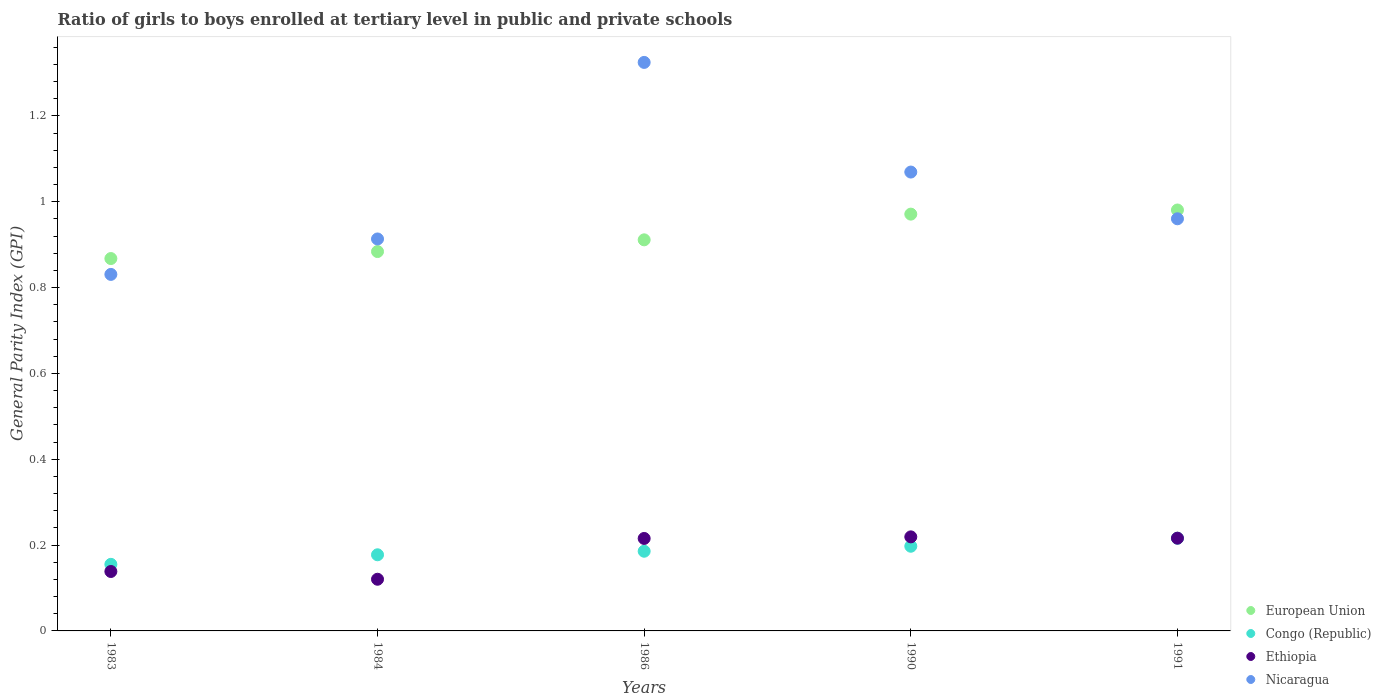Is the number of dotlines equal to the number of legend labels?
Give a very brief answer. Yes. What is the general parity index in European Union in 1986?
Offer a very short reply. 0.91. Across all years, what is the maximum general parity index in Ethiopia?
Your answer should be very brief. 0.22. Across all years, what is the minimum general parity index in European Union?
Provide a short and direct response. 0.87. In which year was the general parity index in European Union maximum?
Your answer should be very brief. 1991. In which year was the general parity index in Nicaragua minimum?
Give a very brief answer. 1983. What is the total general parity index in European Union in the graph?
Keep it short and to the point. 4.62. What is the difference between the general parity index in Ethiopia in 1984 and that in 1991?
Give a very brief answer. -0.1. What is the difference between the general parity index in European Union in 1983 and the general parity index in Ethiopia in 1990?
Make the answer very short. 0.65. What is the average general parity index in Congo (Republic) per year?
Your response must be concise. 0.19. In the year 1986, what is the difference between the general parity index in Congo (Republic) and general parity index in Nicaragua?
Provide a short and direct response. -1.14. In how many years, is the general parity index in European Union greater than 1.12?
Provide a short and direct response. 0. What is the ratio of the general parity index in European Union in 1986 to that in 1991?
Offer a very short reply. 0.93. Is the general parity index in European Union in 1986 less than that in 1990?
Give a very brief answer. Yes. Is the difference between the general parity index in Congo (Republic) in 1986 and 1990 greater than the difference between the general parity index in Nicaragua in 1986 and 1990?
Your answer should be compact. No. What is the difference between the highest and the second highest general parity index in Ethiopia?
Give a very brief answer. 0. What is the difference between the highest and the lowest general parity index in Congo (Republic)?
Your answer should be compact. 0.06. In how many years, is the general parity index in Congo (Republic) greater than the average general parity index in Congo (Republic) taken over all years?
Offer a terse response. 2. Is the sum of the general parity index in Ethiopia in 1984 and 1990 greater than the maximum general parity index in European Union across all years?
Offer a very short reply. No. Is it the case that in every year, the sum of the general parity index in Congo (Republic) and general parity index in European Union  is greater than the sum of general parity index in Ethiopia and general parity index in Nicaragua?
Your answer should be compact. No. Is the general parity index in Ethiopia strictly greater than the general parity index in European Union over the years?
Your response must be concise. No. Are the values on the major ticks of Y-axis written in scientific E-notation?
Give a very brief answer. No. Does the graph contain any zero values?
Ensure brevity in your answer.  No. Where does the legend appear in the graph?
Keep it short and to the point. Bottom right. How many legend labels are there?
Provide a short and direct response. 4. What is the title of the graph?
Provide a short and direct response. Ratio of girls to boys enrolled at tertiary level in public and private schools. Does "Bhutan" appear as one of the legend labels in the graph?
Offer a terse response. No. What is the label or title of the X-axis?
Offer a very short reply. Years. What is the label or title of the Y-axis?
Offer a very short reply. General Parity Index (GPI). What is the General Parity Index (GPI) of European Union in 1983?
Ensure brevity in your answer.  0.87. What is the General Parity Index (GPI) in Congo (Republic) in 1983?
Your response must be concise. 0.16. What is the General Parity Index (GPI) in Ethiopia in 1983?
Keep it short and to the point. 0.14. What is the General Parity Index (GPI) of Nicaragua in 1983?
Your response must be concise. 0.83. What is the General Parity Index (GPI) of European Union in 1984?
Offer a terse response. 0.88. What is the General Parity Index (GPI) in Congo (Republic) in 1984?
Your answer should be compact. 0.18. What is the General Parity Index (GPI) of Ethiopia in 1984?
Provide a succinct answer. 0.12. What is the General Parity Index (GPI) of Nicaragua in 1984?
Your answer should be very brief. 0.91. What is the General Parity Index (GPI) of European Union in 1986?
Give a very brief answer. 0.91. What is the General Parity Index (GPI) in Congo (Republic) in 1986?
Your response must be concise. 0.19. What is the General Parity Index (GPI) of Ethiopia in 1986?
Give a very brief answer. 0.22. What is the General Parity Index (GPI) in Nicaragua in 1986?
Your answer should be very brief. 1.32. What is the General Parity Index (GPI) of European Union in 1990?
Give a very brief answer. 0.97. What is the General Parity Index (GPI) in Congo (Republic) in 1990?
Provide a short and direct response. 0.2. What is the General Parity Index (GPI) in Ethiopia in 1990?
Provide a short and direct response. 0.22. What is the General Parity Index (GPI) in Nicaragua in 1990?
Provide a short and direct response. 1.07. What is the General Parity Index (GPI) of European Union in 1991?
Make the answer very short. 0.98. What is the General Parity Index (GPI) of Congo (Republic) in 1991?
Keep it short and to the point. 0.22. What is the General Parity Index (GPI) of Ethiopia in 1991?
Provide a succinct answer. 0.22. What is the General Parity Index (GPI) in Nicaragua in 1991?
Keep it short and to the point. 0.96. Across all years, what is the maximum General Parity Index (GPI) of European Union?
Ensure brevity in your answer.  0.98. Across all years, what is the maximum General Parity Index (GPI) in Congo (Republic)?
Make the answer very short. 0.22. Across all years, what is the maximum General Parity Index (GPI) in Ethiopia?
Your response must be concise. 0.22. Across all years, what is the maximum General Parity Index (GPI) of Nicaragua?
Ensure brevity in your answer.  1.32. Across all years, what is the minimum General Parity Index (GPI) in European Union?
Ensure brevity in your answer.  0.87. Across all years, what is the minimum General Parity Index (GPI) in Congo (Republic)?
Your answer should be very brief. 0.16. Across all years, what is the minimum General Parity Index (GPI) of Ethiopia?
Offer a very short reply. 0.12. Across all years, what is the minimum General Parity Index (GPI) of Nicaragua?
Your answer should be very brief. 0.83. What is the total General Parity Index (GPI) of European Union in the graph?
Ensure brevity in your answer.  4.62. What is the total General Parity Index (GPI) in Congo (Republic) in the graph?
Provide a short and direct response. 0.93. What is the total General Parity Index (GPI) of Ethiopia in the graph?
Provide a succinct answer. 0.91. What is the total General Parity Index (GPI) in Nicaragua in the graph?
Provide a succinct answer. 5.1. What is the difference between the General Parity Index (GPI) of European Union in 1983 and that in 1984?
Your answer should be compact. -0.02. What is the difference between the General Parity Index (GPI) in Congo (Republic) in 1983 and that in 1984?
Your answer should be very brief. -0.02. What is the difference between the General Parity Index (GPI) in Ethiopia in 1983 and that in 1984?
Your response must be concise. 0.02. What is the difference between the General Parity Index (GPI) of Nicaragua in 1983 and that in 1984?
Make the answer very short. -0.08. What is the difference between the General Parity Index (GPI) in European Union in 1983 and that in 1986?
Make the answer very short. -0.04. What is the difference between the General Parity Index (GPI) of Congo (Republic) in 1983 and that in 1986?
Ensure brevity in your answer.  -0.03. What is the difference between the General Parity Index (GPI) in Ethiopia in 1983 and that in 1986?
Offer a terse response. -0.08. What is the difference between the General Parity Index (GPI) in Nicaragua in 1983 and that in 1986?
Ensure brevity in your answer.  -0.49. What is the difference between the General Parity Index (GPI) in European Union in 1983 and that in 1990?
Provide a short and direct response. -0.1. What is the difference between the General Parity Index (GPI) in Congo (Republic) in 1983 and that in 1990?
Give a very brief answer. -0.04. What is the difference between the General Parity Index (GPI) in Ethiopia in 1983 and that in 1990?
Keep it short and to the point. -0.08. What is the difference between the General Parity Index (GPI) in Nicaragua in 1983 and that in 1990?
Provide a succinct answer. -0.24. What is the difference between the General Parity Index (GPI) in European Union in 1983 and that in 1991?
Your answer should be compact. -0.11. What is the difference between the General Parity Index (GPI) in Congo (Republic) in 1983 and that in 1991?
Provide a succinct answer. -0.06. What is the difference between the General Parity Index (GPI) in Ethiopia in 1983 and that in 1991?
Provide a succinct answer. -0.08. What is the difference between the General Parity Index (GPI) in Nicaragua in 1983 and that in 1991?
Your answer should be compact. -0.13. What is the difference between the General Parity Index (GPI) in European Union in 1984 and that in 1986?
Ensure brevity in your answer.  -0.03. What is the difference between the General Parity Index (GPI) in Congo (Republic) in 1984 and that in 1986?
Your response must be concise. -0.01. What is the difference between the General Parity Index (GPI) in Ethiopia in 1984 and that in 1986?
Make the answer very short. -0.1. What is the difference between the General Parity Index (GPI) in Nicaragua in 1984 and that in 1986?
Provide a succinct answer. -0.41. What is the difference between the General Parity Index (GPI) of European Union in 1984 and that in 1990?
Provide a succinct answer. -0.09. What is the difference between the General Parity Index (GPI) in Congo (Republic) in 1984 and that in 1990?
Make the answer very short. -0.02. What is the difference between the General Parity Index (GPI) of Ethiopia in 1984 and that in 1990?
Your response must be concise. -0.1. What is the difference between the General Parity Index (GPI) of Nicaragua in 1984 and that in 1990?
Your answer should be very brief. -0.16. What is the difference between the General Parity Index (GPI) in European Union in 1984 and that in 1991?
Keep it short and to the point. -0.1. What is the difference between the General Parity Index (GPI) in Congo (Republic) in 1984 and that in 1991?
Provide a short and direct response. -0.04. What is the difference between the General Parity Index (GPI) of Ethiopia in 1984 and that in 1991?
Give a very brief answer. -0.1. What is the difference between the General Parity Index (GPI) of Nicaragua in 1984 and that in 1991?
Offer a very short reply. -0.05. What is the difference between the General Parity Index (GPI) in European Union in 1986 and that in 1990?
Your answer should be very brief. -0.06. What is the difference between the General Parity Index (GPI) in Congo (Republic) in 1986 and that in 1990?
Give a very brief answer. -0.01. What is the difference between the General Parity Index (GPI) in Ethiopia in 1986 and that in 1990?
Provide a succinct answer. -0. What is the difference between the General Parity Index (GPI) of Nicaragua in 1986 and that in 1990?
Offer a very short reply. 0.26. What is the difference between the General Parity Index (GPI) in European Union in 1986 and that in 1991?
Provide a short and direct response. -0.07. What is the difference between the General Parity Index (GPI) in Congo (Republic) in 1986 and that in 1991?
Make the answer very short. -0.03. What is the difference between the General Parity Index (GPI) of Ethiopia in 1986 and that in 1991?
Give a very brief answer. -0. What is the difference between the General Parity Index (GPI) of Nicaragua in 1986 and that in 1991?
Your answer should be compact. 0.36. What is the difference between the General Parity Index (GPI) in European Union in 1990 and that in 1991?
Offer a very short reply. -0.01. What is the difference between the General Parity Index (GPI) of Congo (Republic) in 1990 and that in 1991?
Offer a terse response. -0.02. What is the difference between the General Parity Index (GPI) of Ethiopia in 1990 and that in 1991?
Provide a succinct answer. 0. What is the difference between the General Parity Index (GPI) of Nicaragua in 1990 and that in 1991?
Provide a short and direct response. 0.11. What is the difference between the General Parity Index (GPI) of European Union in 1983 and the General Parity Index (GPI) of Congo (Republic) in 1984?
Your answer should be very brief. 0.69. What is the difference between the General Parity Index (GPI) of European Union in 1983 and the General Parity Index (GPI) of Ethiopia in 1984?
Your response must be concise. 0.75. What is the difference between the General Parity Index (GPI) in European Union in 1983 and the General Parity Index (GPI) in Nicaragua in 1984?
Offer a terse response. -0.05. What is the difference between the General Parity Index (GPI) in Congo (Republic) in 1983 and the General Parity Index (GPI) in Ethiopia in 1984?
Your answer should be very brief. 0.03. What is the difference between the General Parity Index (GPI) of Congo (Republic) in 1983 and the General Parity Index (GPI) of Nicaragua in 1984?
Offer a terse response. -0.76. What is the difference between the General Parity Index (GPI) of Ethiopia in 1983 and the General Parity Index (GPI) of Nicaragua in 1984?
Provide a succinct answer. -0.77. What is the difference between the General Parity Index (GPI) of European Union in 1983 and the General Parity Index (GPI) of Congo (Republic) in 1986?
Your answer should be compact. 0.68. What is the difference between the General Parity Index (GPI) in European Union in 1983 and the General Parity Index (GPI) in Ethiopia in 1986?
Your answer should be compact. 0.65. What is the difference between the General Parity Index (GPI) of European Union in 1983 and the General Parity Index (GPI) of Nicaragua in 1986?
Your answer should be compact. -0.46. What is the difference between the General Parity Index (GPI) in Congo (Republic) in 1983 and the General Parity Index (GPI) in Ethiopia in 1986?
Your answer should be compact. -0.06. What is the difference between the General Parity Index (GPI) in Congo (Republic) in 1983 and the General Parity Index (GPI) in Nicaragua in 1986?
Keep it short and to the point. -1.17. What is the difference between the General Parity Index (GPI) of Ethiopia in 1983 and the General Parity Index (GPI) of Nicaragua in 1986?
Your answer should be compact. -1.19. What is the difference between the General Parity Index (GPI) in European Union in 1983 and the General Parity Index (GPI) in Congo (Republic) in 1990?
Make the answer very short. 0.67. What is the difference between the General Parity Index (GPI) of European Union in 1983 and the General Parity Index (GPI) of Ethiopia in 1990?
Your answer should be compact. 0.65. What is the difference between the General Parity Index (GPI) in European Union in 1983 and the General Parity Index (GPI) in Nicaragua in 1990?
Provide a succinct answer. -0.2. What is the difference between the General Parity Index (GPI) of Congo (Republic) in 1983 and the General Parity Index (GPI) of Ethiopia in 1990?
Keep it short and to the point. -0.06. What is the difference between the General Parity Index (GPI) in Congo (Republic) in 1983 and the General Parity Index (GPI) in Nicaragua in 1990?
Your response must be concise. -0.91. What is the difference between the General Parity Index (GPI) in Ethiopia in 1983 and the General Parity Index (GPI) in Nicaragua in 1990?
Offer a terse response. -0.93. What is the difference between the General Parity Index (GPI) of European Union in 1983 and the General Parity Index (GPI) of Congo (Republic) in 1991?
Keep it short and to the point. 0.65. What is the difference between the General Parity Index (GPI) in European Union in 1983 and the General Parity Index (GPI) in Ethiopia in 1991?
Your answer should be very brief. 0.65. What is the difference between the General Parity Index (GPI) in European Union in 1983 and the General Parity Index (GPI) in Nicaragua in 1991?
Offer a terse response. -0.09. What is the difference between the General Parity Index (GPI) in Congo (Republic) in 1983 and the General Parity Index (GPI) in Ethiopia in 1991?
Your answer should be compact. -0.06. What is the difference between the General Parity Index (GPI) of Congo (Republic) in 1983 and the General Parity Index (GPI) of Nicaragua in 1991?
Ensure brevity in your answer.  -0.81. What is the difference between the General Parity Index (GPI) of Ethiopia in 1983 and the General Parity Index (GPI) of Nicaragua in 1991?
Make the answer very short. -0.82. What is the difference between the General Parity Index (GPI) of European Union in 1984 and the General Parity Index (GPI) of Congo (Republic) in 1986?
Provide a short and direct response. 0.7. What is the difference between the General Parity Index (GPI) in European Union in 1984 and the General Parity Index (GPI) in Ethiopia in 1986?
Your response must be concise. 0.67. What is the difference between the General Parity Index (GPI) in European Union in 1984 and the General Parity Index (GPI) in Nicaragua in 1986?
Ensure brevity in your answer.  -0.44. What is the difference between the General Parity Index (GPI) in Congo (Republic) in 1984 and the General Parity Index (GPI) in Ethiopia in 1986?
Your response must be concise. -0.04. What is the difference between the General Parity Index (GPI) in Congo (Republic) in 1984 and the General Parity Index (GPI) in Nicaragua in 1986?
Offer a very short reply. -1.15. What is the difference between the General Parity Index (GPI) of Ethiopia in 1984 and the General Parity Index (GPI) of Nicaragua in 1986?
Provide a succinct answer. -1.2. What is the difference between the General Parity Index (GPI) in European Union in 1984 and the General Parity Index (GPI) in Congo (Republic) in 1990?
Ensure brevity in your answer.  0.69. What is the difference between the General Parity Index (GPI) in European Union in 1984 and the General Parity Index (GPI) in Ethiopia in 1990?
Make the answer very short. 0.66. What is the difference between the General Parity Index (GPI) in European Union in 1984 and the General Parity Index (GPI) in Nicaragua in 1990?
Your answer should be compact. -0.19. What is the difference between the General Parity Index (GPI) of Congo (Republic) in 1984 and the General Parity Index (GPI) of Ethiopia in 1990?
Provide a succinct answer. -0.04. What is the difference between the General Parity Index (GPI) in Congo (Republic) in 1984 and the General Parity Index (GPI) in Nicaragua in 1990?
Your response must be concise. -0.89. What is the difference between the General Parity Index (GPI) of Ethiopia in 1984 and the General Parity Index (GPI) of Nicaragua in 1990?
Offer a very short reply. -0.95. What is the difference between the General Parity Index (GPI) in European Union in 1984 and the General Parity Index (GPI) in Congo (Republic) in 1991?
Give a very brief answer. 0.67. What is the difference between the General Parity Index (GPI) in European Union in 1984 and the General Parity Index (GPI) in Ethiopia in 1991?
Give a very brief answer. 0.67. What is the difference between the General Parity Index (GPI) of European Union in 1984 and the General Parity Index (GPI) of Nicaragua in 1991?
Provide a succinct answer. -0.08. What is the difference between the General Parity Index (GPI) in Congo (Republic) in 1984 and the General Parity Index (GPI) in Ethiopia in 1991?
Ensure brevity in your answer.  -0.04. What is the difference between the General Parity Index (GPI) of Congo (Republic) in 1984 and the General Parity Index (GPI) of Nicaragua in 1991?
Your answer should be very brief. -0.78. What is the difference between the General Parity Index (GPI) in Ethiopia in 1984 and the General Parity Index (GPI) in Nicaragua in 1991?
Provide a succinct answer. -0.84. What is the difference between the General Parity Index (GPI) in European Union in 1986 and the General Parity Index (GPI) in Congo (Republic) in 1990?
Make the answer very short. 0.71. What is the difference between the General Parity Index (GPI) of European Union in 1986 and the General Parity Index (GPI) of Ethiopia in 1990?
Offer a very short reply. 0.69. What is the difference between the General Parity Index (GPI) in European Union in 1986 and the General Parity Index (GPI) in Nicaragua in 1990?
Keep it short and to the point. -0.16. What is the difference between the General Parity Index (GPI) in Congo (Republic) in 1986 and the General Parity Index (GPI) in Ethiopia in 1990?
Offer a terse response. -0.03. What is the difference between the General Parity Index (GPI) of Congo (Republic) in 1986 and the General Parity Index (GPI) of Nicaragua in 1990?
Provide a short and direct response. -0.88. What is the difference between the General Parity Index (GPI) of Ethiopia in 1986 and the General Parity Index (GPI) of Nicaragua in 1990?
Provide a succinct answer. -0.85. What is the difference between the General Parity Index (GPI) of European Union in 1986 and the General Parity Index (GPI) of Congo (Republic) in 1991?
Make the answer very short. 0.7. What is the difference between the General Parity Index (GPI) in European Union in 1986 and the General Parity Index (GPI) in Ethiopia in 1991?
Provide a short and direct response. 0.7. What is the difference between the General Parity Index (GPI) of European Union in 1986 and the General Parity Index (GPI) of Nicaragua in 1991?
Make the answer very short. -0.05. What is the difference between the General Parity Index (GPI) of Congo (Republic) in 1986 and the General Parity Index (GPI) of Ethiopia in 1991?
Give a very brief answer. -0.03. What is the difference between the General Parity Index (GPI) in Congo (Republic) in 1986 and the General Parity Index (GPI) in Nicaragua in 1991?
Keep it short and to the point. -0.77. What is the difference between the General Parity Index (GPI) in Ethiopia in 1986 and the General Parity Index (GPI) in Nicaragua in 1991?
Your answer should be very brief. -0.74. What is the difference between the General Parity Index (GPI) of European Union in 1990 and the General Parity Index (GPI) of Congo (Republic) in 1991?
Your response must be concise. 0.76. What is the difference between the General Parity Index (GPI) in European Union in 1990 and the General Parity Index (GPI) in Ethiopia in 1991?
Give a very brief answer. 0.76. What is the difference between the General Parity Index (GPI) of European Union in 1990 and the General Parity Index (GPI) of Nicaragua in 1991?
Your response must be concise. 0.01. What is the difference between the General Parity Index (GPI) of Congo (Republic) in 1990 and the General Parity Index (GPI) of Ethiopia in 1991?
Offer a terse response. -0.02. What is the difference between the General Parity Index (GPI) of Congo (Republic) in 1990 and the General Parity Index (GPI) of Nicaragua in 1991?
Offer a very short reply. -0.76. What is the difference between the General Parity Index (GPI) in Ethiopia in 1990 and the General Parity Index (GPI) in Nicaragua in 1991?
Ensure brevity in your answer.  -0.74. What is the average General Parity Index (GPI) in European Union per year?
Your answer should be very brief. 0.92. What is the average General Parity Index (GPI) of Congo (Republic) per year?
Keep it short and to the point. 0.19. What is the average General Parity Index (GPI) of Ethiopia per year?
Offer a very short reply. 0.18. What is the average General Parity Index (GPI) of Nicaragua per year?
Provide a short and direct response. 1.02. In the year 1983, what is the difference between the General Parity Index (GPI) of European Union and General Parity Index (GPI) of Congo (Republic)?
Offer a very short reply. 0.71. In the year 1983, what is the difference between the General Parity Index (GPI) in European Union and General Parity Index (GPI) in Ethiopia?
Offer a very short reply. 0.73. In the year 1983, what is the difference between the General Parity Index (GPI) in European Union and General Parity Index (GPI) in Nicaragua?
Make the answer very short. 0.04. In the year 1983, what is the difference between the General Parity Index (GPI) in Congo (Republic) and General Parity Index (GPI) in Ethiopia?
Keep it short and to the point. 0.02. In the year 1983, what is the difference between the General Parity Index (GPI) of Congo (Republic) and General Parity Index (GPI) of Nicaragua?
Ensure brevity in your answer.  -0.68. In the year 1983, what is the difference between the General Parity Index (GPI) of Ethiopia and General Parity Index (GPI) of Nicaragua?
Your answer should be compact. -0.69. In the year 1984, what is the difference between the General Parity Index (GPI) of European Union and General Parity Index (GPI) of Congo (Republic)?
Make the answer very short. 0.71. In the year 1984, what is the difference between the General Parity Index (GPI) of European Union and General Parity Index (GPI) of Ethiopia?
Your answer should be compact. 0.76. In the year 1984, what is the difference between the General Parity Index (GPI) in European Union and General Parity Index (GPI) in Nicaragua?
Make the answer very short. -0.03. In the year 1984, what is the difference between the General Parity Index (GPI) in Congo (Republic) and General Parity Index (GPI) in Ethiopia?
Ensure brevity in your answer.  0.06. In the year 1984, what is the difference between the General Parity Index (GPI) in Congo (Republic) and General Parity Index (GPI) in Nicaragua?
Offer a very short reply. -0.74. In the year 1984, what is the difference between the General Parity Index (GPI) of Ethiopia and General Parity Index (GPI) of Nicaragua?
Ensure brevity in your answer.  -0.79. In the year 1986, what is the difference between the General Parity Index (GPI) in European Union and General Parity Index (GPI) in Congo (Republic)?
Provide a short and direct response. 0.73. In the year 1986, what is the difference between the General Parity Index (GPI) in European Union and General Parity Index (GPI) in Ethiopia?
Offer a very short reply. 0.7. In the year 1986, what is the difference between the General Parity Index (GPI) in European Union and General Parity Index (GPI) in Nicaragua?
Your answer should be compact. -0.41. In the year 1986, what is the difference between the General Parity Index (GPI) in Congo (Republic) and General Parity Index (GPI) in Ethiopia?
Offer a very short reply. -0.03. In the year 1986, what is the difference between the General Parity Index (GPI) in Congo (Republic) and General Parity Index (GPI) in Nicaragua?
Ensure brevity in your answer.  -1.14. In the year 1986, what is the difference between the General Parity Index (GPI) in Ethiopia and General Parity Index (GPI) in Nicaragua?
Your answer should be compact. -1.11. In the year 1990, what is the difference between the General Parity Index (GPI) in European Union and General Parity Index (GPI) in Congo (Republic)?
Your answer should be compact. 0.77. In the year 1990, what is the difference between the General Parity Index (GPI) of European Union and General Parity Index (GPI) of Ethiopia?
Your answer should be very brief. 0.75. In the year 1990, what is the difference between the General Parity Index (GPI) in European Union and General Parity Index (GPI) in Nicaragua?
Offer a terse response. -0.1. In the year 1990, what is the difference between the General Parity Index (GPI) of Congo (Republic) and General Parity Index (GPI) of Ethiopia?
Your answer should be very brief. -0.02. In the year 1990, what is the difference between the General Parity Index (GPI) in Congo (Republic) and General Parity Index (GPI) in Nicaragua?
Your response must be concise. -0.87. In the year 1990, what is the difference between the General Parity Index (GPI) of Ethiopia and General Parity Index (GPI) of Nicaragua?
Provide a short and direct response. -0.85. In the year 1991, what is the difference between the General Parity Index (GPI) in European Union and General Parity Index (GPI) in Congo (Republic)?
Provide a short and direct response. 0.77. In the year 1991, what is the difference between the General Parity Index (GPI) in European Union and General Parity Index (GPI) in Ethiopia?
Your answer should be compact. 0.76. In the year 1991, what is the difference between the General Parity Index (GPI) in European Union and General Parity Index (GPI) in Nicaragua?
Ensure brevity in your answer.  0.02. In the year 1991, what is the difference between the General Parity Index (GPI) in Congo (Republic) and General Parity Index (GPI) in Ethiopia?
Ensure brevity in your answer.  -0. In the year 1991, what is the difference between the General Parity Index (GPI) in Congo (Republic) and General Parity Index (GPI) in Nicaragua?
Your answer should be very brief. -0.74. In the year 1991, what is the difference between the General Parity Index (GPI) in Ethiopia and General Parity Index (GPI) in Nicaragua?
Your answer should be compact. -0.74. What is the ratio of the General Parity Index (GPI) in European Union in 1983 to that in 1984?
Your answer should be very brief. 0.98. What is the ratio of the General Parity Index (GPI) of Congo (Republic) in 1983 to that in 1984?
Make the answer very short. 0.87. What is the ratio of the General Parity Index (GPI) of Ethiopia in 1983 to that in 1984?
Offer a terse response. 1.15. What is the ratio of the General Parity Index (GPI) in Nicaragua in 1983 to that in 1984?
Give a very brief answer. 0.91. What is the ratio of the General Parity Index (GPI) in European Union in 1983 to that in 1986?
Make the answer very short. 0.95. What is the ratio of the General Parity Index (GPI) in Congo (Republic) in 1983 to that in 1986?
Your answer should be very brief. 0.84. What is the ratio of the General Parity Index (GPI) of Ethiopia in 1983 to that in 1986?
Provide a short and direct response. 0.64. What is the ratio of the General Parity Index (GPI) of Nicaragua in 1983 to that in 1986?
Keep it short and to the point. 0.63. What is the ratio of the General Parity Index (GPI) in European Union in 1983 to that in 1990?
Your answer should be compact. 0.89. What is the ratio of the General Parity Index (GPI) of Congo (Republic) in 1983 to that in 1990?
Provide a short and direct response. 0.79. What is the ratio of the General Parity Index (GPI) in Ethiopia in 1983 to that in 1990?
Keep it short and to the point. 0.63. What is the ratio of the General Parity Index (GPI) in Nicaragua in 1983 to that in 1990?
Offer a very short reply. 0.78. What is the ratio of the General Parity Index (GPI) in European Union in 1983 to that in 1991?
Provide a succinct answer. 0.88. What is the ratio of the General Parity Index (GPI) in Congo (Republic) in 1983 to that in 1991?
Offer a very short reply. 0.72. What is the ratio of the General Parity Index (GPI) in Ethiopia in 1983 to that in 1991?
Offer a terse response. 0.64. What is the ratio of the General Parity Index (GPI) in Nicaragua in 1983 to that in 1991?
Give a very brief answer. 0.86. What is the ratio of the General Parity Index (GPI) of Congo (Republic) in 1984 to that in 1986?
Ensure brevity in your answer.  0.96. What is the ratio of the General Parity Index (GPI) in Ethiopia in 1984 to that in 1986?
Your answer should be compact. 0.56. What is the ratio of the General Parity Index (GPI) in Nicaragua in 1984 to that in 1986?
Offer a very short reply. 0.69. What is the ratio of the General Parity Index (GPI) of European Union in 1984 to that in 1990?
Offer a very short reply. 0.91. What is the ratio of the General Parity Index (GPI) of Congo (Republic) in 1984 to that in 1990?
Make the answer very short. 0.9. What is the ratio of the General Parity Index (GPI) in Ethiopia in 1984 to that in 1990?
Your answer should be compact. 0.55. What is the ratio of the General Parity Index (GPI) of Nicaragua in 1984 to that in 1990?
Ensure brevity in your answer.  0.85. What is the ratio of the General Parity Index (GPI) in European Union in 1984 to that in 1991?
Make the answer very short. 0.9. What is the ratio of the General Parity Index (GPI) of Congo (Republic) in 1984 to that in 1991?
Your answer should be very brief. 0.82. What is the ratio of the General Parity Index (GPI) of Ethiopia in 1984 to that in 1991?
Offer a very short reply. 0.56. What is the ratio of the General Parity Index (GPI) of Nicaragua in 1984 to that in 1991?
Provide a short and direct response. 0.95. What is the ratio of the General Parity Index (GPI) of European Union in 1986 to that in 1990?
Your response must be concise. 0.94. What is the ratio of the General Parity Index (GPI) in Congo (Republic) in 1986 to that in 1990?
Give a very brief answer. 0.94. What is the ratio of the General Parity Index (GPI) of Ethiopia in 1986 to that in 1990?
Make the answer very short. 0.98. What is the ratio of the General Parity Index (GPI) in Nicaragua in 1986 to that in 1990?
Your response must be concise. 1.24. What is the ratio of the General Parity Index (GPI) of European Union in 1986 to that in 1991?
Provide a short and direct response. 0.93. What is the ratio of the General Parity Index (GPI) of Congo (Republic) in 1986 to that in 1991?
Your answer should be compact. 0.86. What is the ratio of the General Parity Index (GPI) in Nicaragua in 1986 to that in 1991?
Make the answer very short. 1.38. What is the ratio of the General Parity Index (GPI) of European Union in 1990 to that in 1991?
Offer a very short reply. 0.99. What is the ratio of the General Parity Index (GPI) in Congo (Republic) in 1990 to that in 1991?
Your answer should be compact. 0.91. What is the ratio of the General Parity Index (GPI) of Ethiopia in 1990 to that in 1991?
Provide a succinct answer. 1.01. What is the ratio of the General Parity Index (GPI) of Nicaragua in 1990 to that in 1991?
Keep it short and to the point. 1.11. What is the difference between the highest and the second highest General Parity Index (GPI) in European Union?
Make the answer very short. 0.01. What is the difference between the highest and the second highest General Parity Index (GPI) in Congo (Republic)?
Your answer should be very brief. 0.02. What is the difference between the highest and the second highest General Parity Index (GPI) in Ethiopia?
Your answer should be compact. 0. What is the difference between the highest and the second highest General Parity Index (GPI) in Nicaragua?
Your answer should be compact. 0.26. What is the difference between the highest and the lowest General Parity Index (GPI) in European Union?
Offer a very short reply. 0.11. What is the difference between the highest and the lowest General Parity Index (GPI) in Congo (Republic)?
Provide a succinct answer. 0.06. What is the difference between the highest and the lowest General Parity Index (GPI) of Ethiopia?
Provide a succinct answer. 0.1. What is the difference between the highest and the lowest General Parity Index (GPI) of Nicaragua?
Keep it short and to the point. 0.49. 